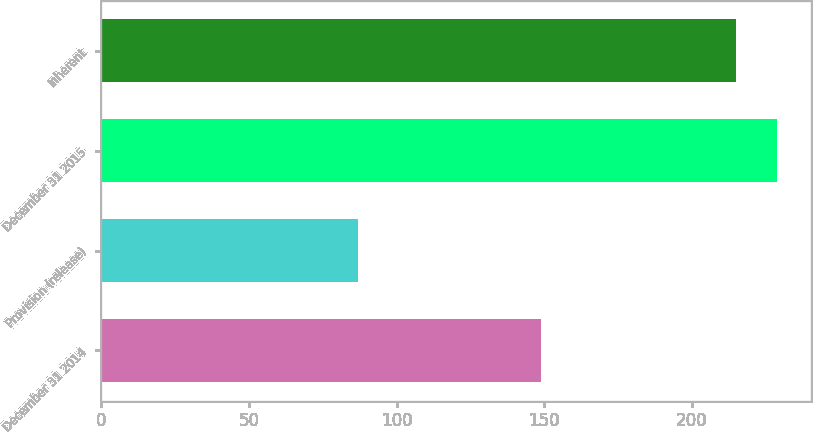Convert chart to OTSL. <chart><loc_0><loc_0><loc_500><loc_500><bar_chart><fcel>December 31 2014<fcel>Provision (release)<fcel>December 31 2015<fcel>Inherent<nl><fcel>149<fcel>87<fcel>228.8<fcel>215<nl></chart> 